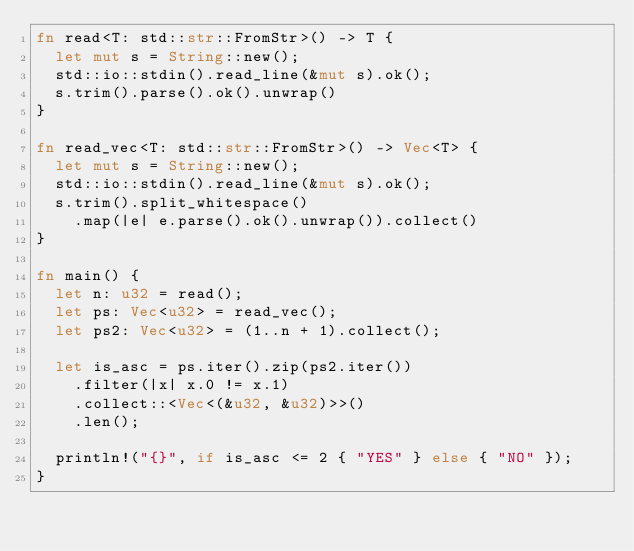Convert code to text. <code><loc_0><loc_0><loc_500><loc_500><_Rust_>fn read<T: std::str::FromStr>() -> T {
  let mut s = String::new();
  std::io::stdin().read_line(&mut s).ok();
  s.trim().parse().ok().unwrap()
}

fn read_vec<T: std::str::FromStr>() -> Vec<T> {
  let mut s = String::new();
  std::io::stdin().read_line(&mut s).ok();
  s.trim().split_whitespace()
    .map(|e| e.parse().ok().unwrap()).collect()
}

fn main() {
  let n: u32 = read();
  let ps: Vec<u32> = read_vec();
  let ps2: Vec<u32> = (1..n + 1).collect();

  let is_asc = ps.iter().zip(ps2.iter())
    .filter(|x| x.0 != x.1)
    .collect::<Vec<(&u32, &u32)>>()
    .len();
  
  println!("{}", if is_asc <= 2 { "YES" } else { "NO" });
}
</code> 